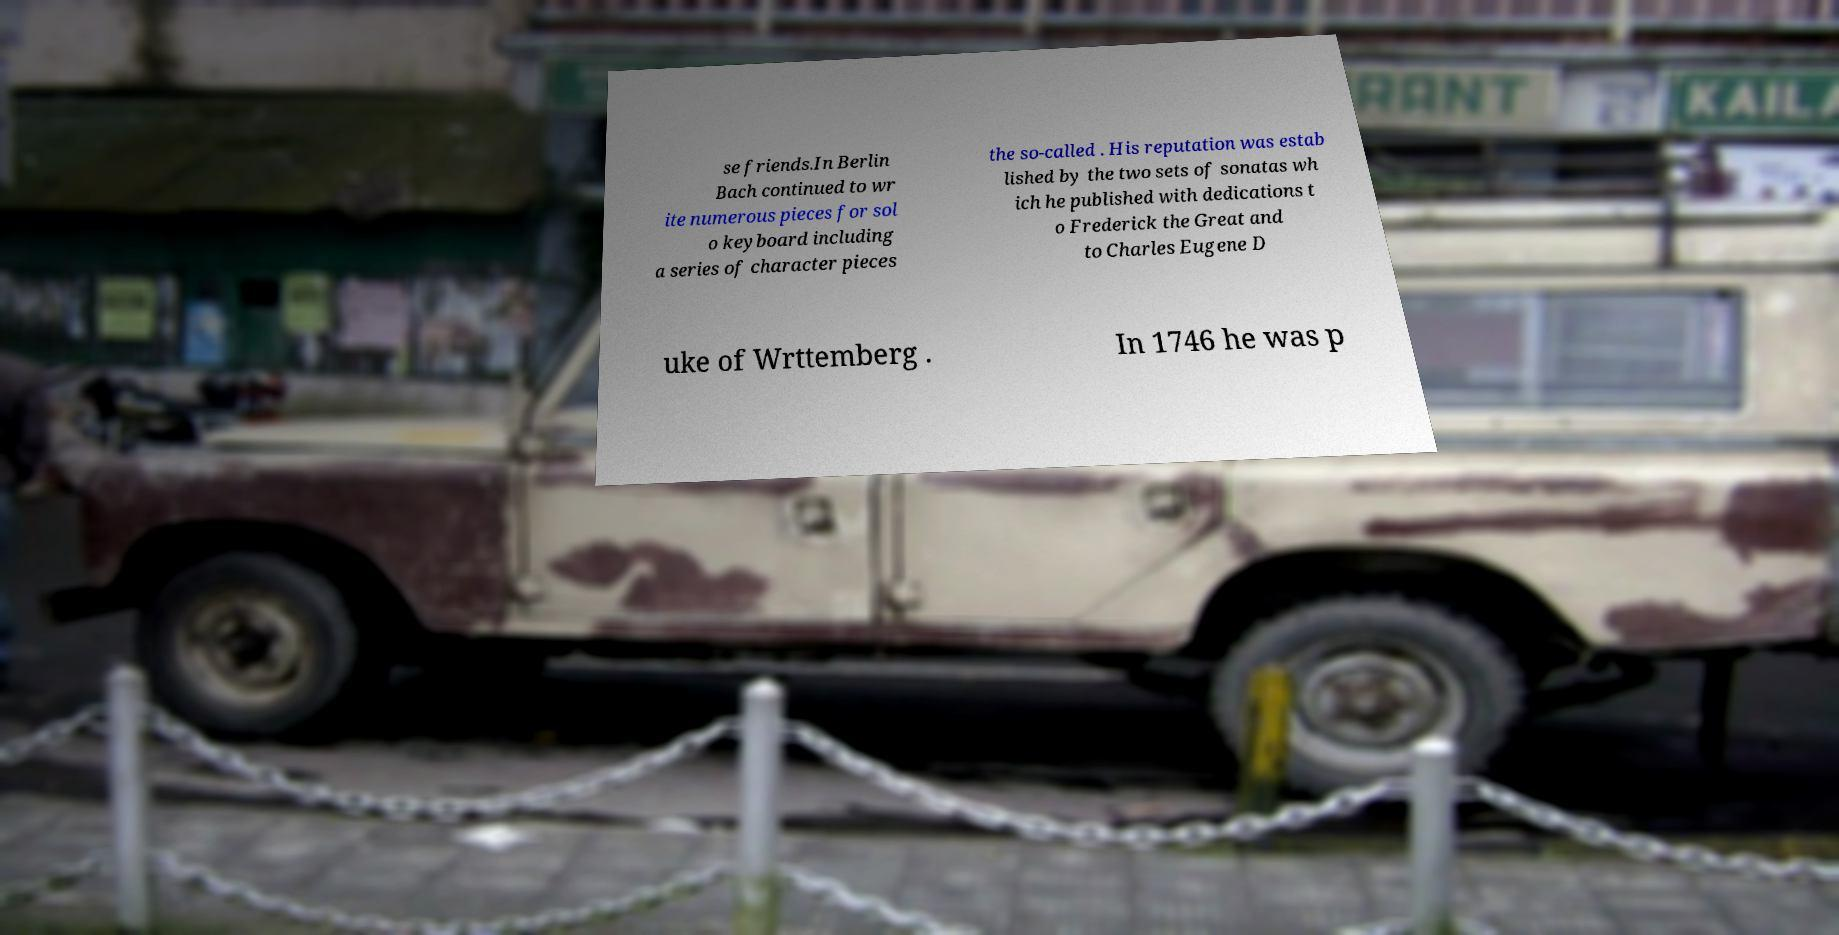Please identify and transcribe the text found in this image. se friends.In Berlin Bach continued to wr ite numerous pieces for sol o keyboard including a series of character pieces the so-called . His reputation was estab lished by the two sets of sonatas wh ich he published with dedications t o Frederick the Great and to Charles Eugene D uke of Wrttemberg . In 1746 he was p 